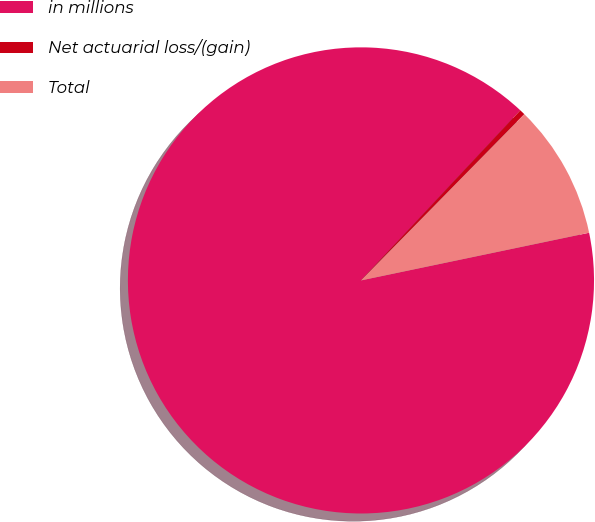Convert chart to OTSL. <chart><loc_0><loc_0><loc_500><loc_500><pie_chart><fcel>in millions<fcel>Net actuarial loss/(gain)<fcel>Total<nl><fcel>90.26%<fcel>0.38%<fcel>9.36%<nl></chart> 